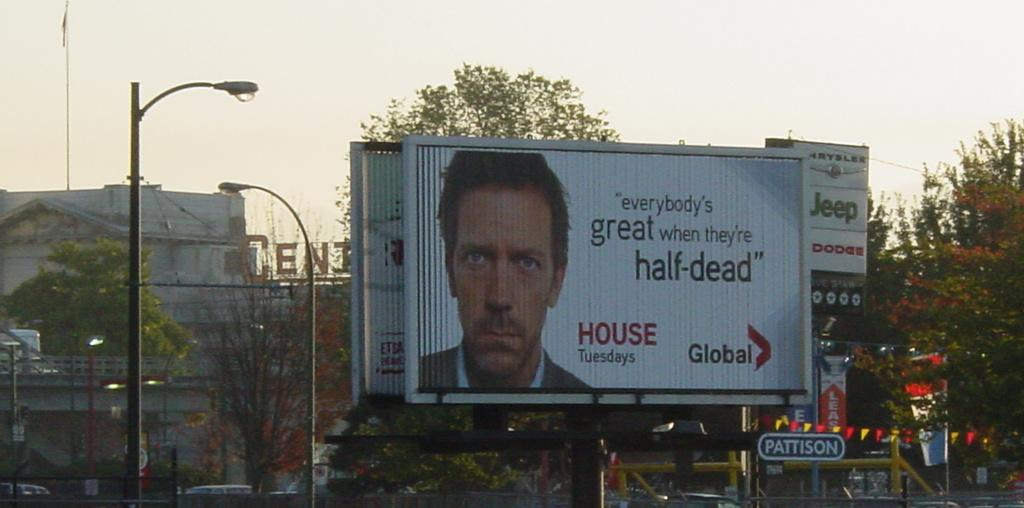Provide a one-sentence caption for the provided image. An advertisement for House is on a billboard in a city. 